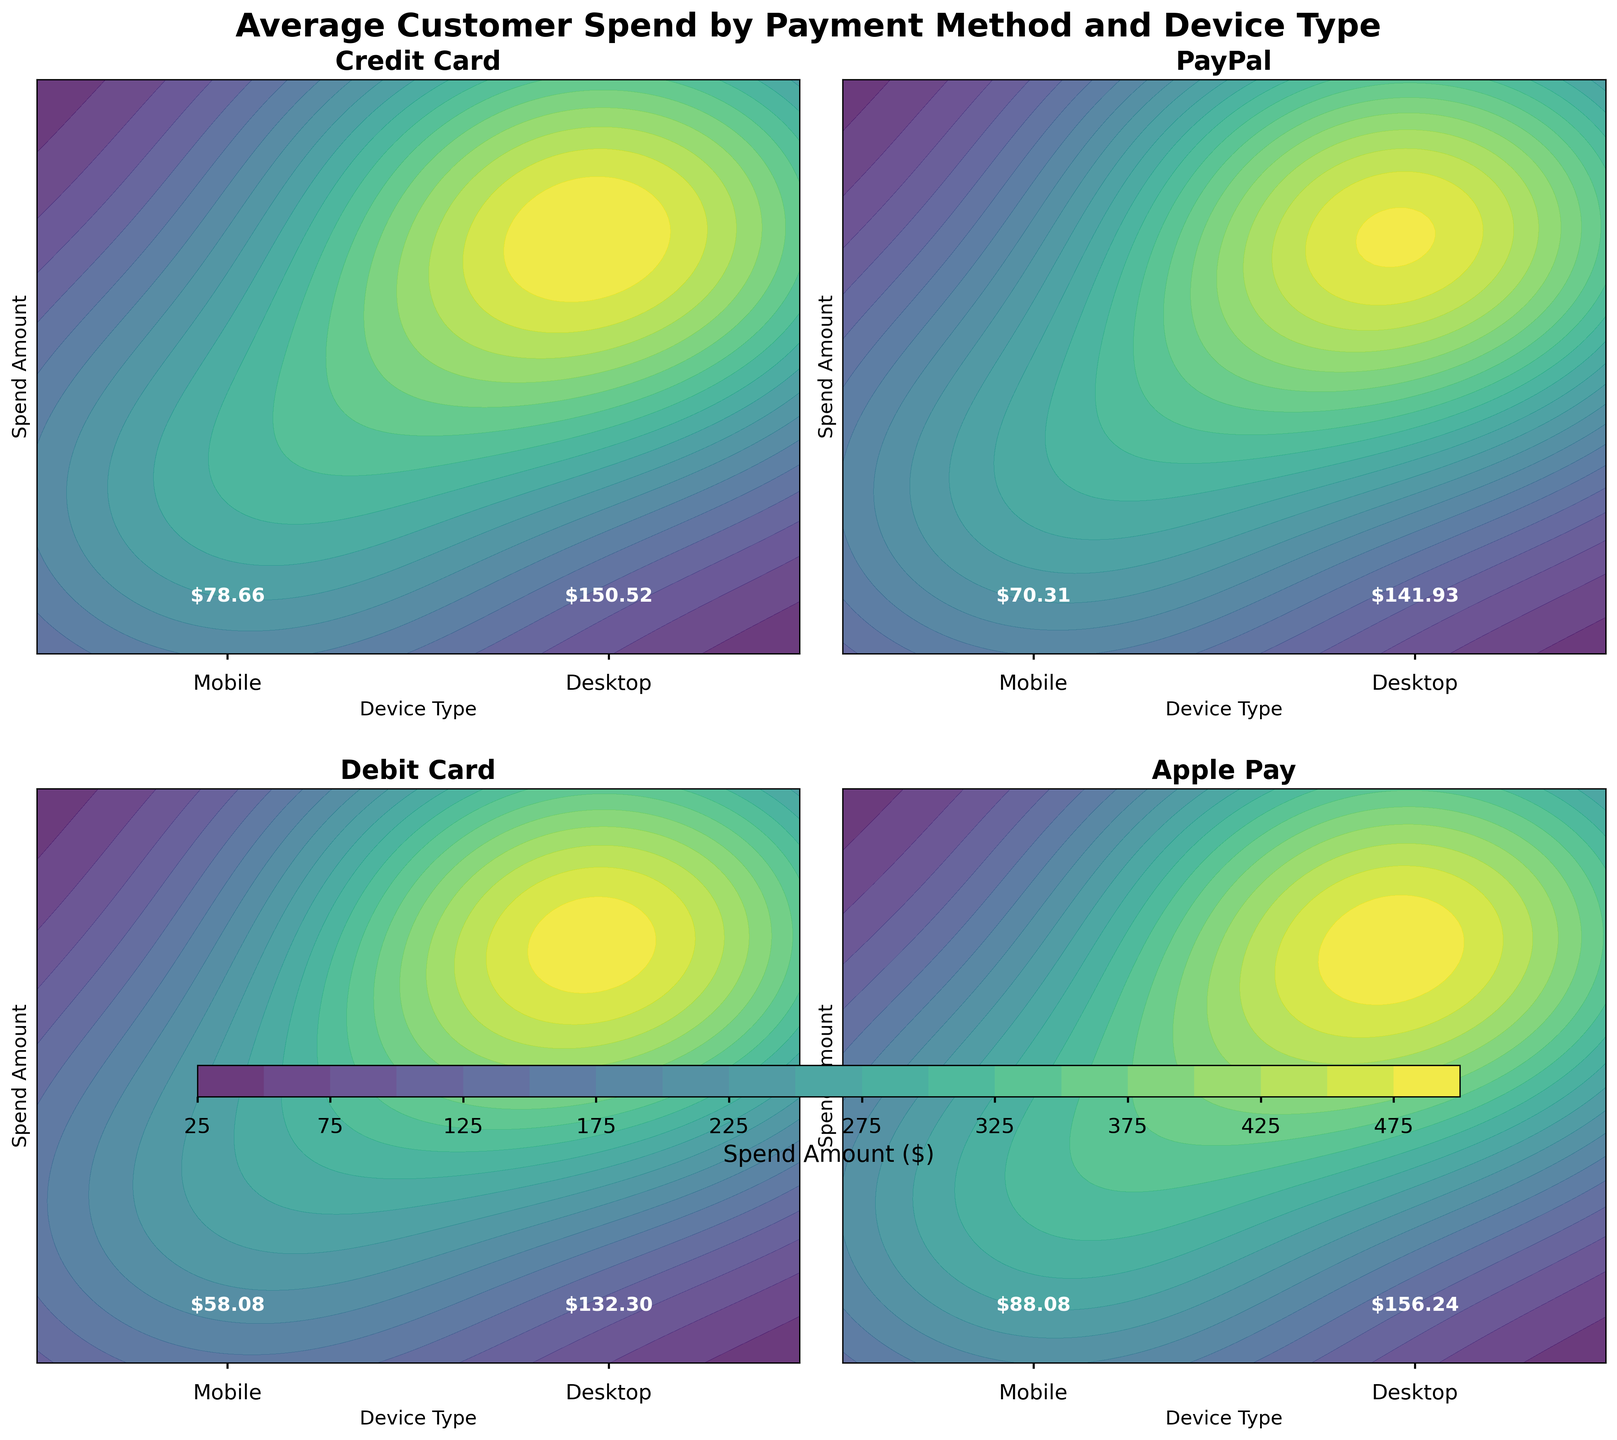What is the title of this figure? The title of the figure is displayed above the subplots and provides the overall theme or subject of the visual data presented in the plots.
Answer: Average Customer Spend by Payment Method and Device Type How many subplots are in the figure? The figure contains a grid of subplots to separately visualize data for each payment method. Counting these boxes helps identify the number of different visualizations presented.
Answer: 4 Which payment method shows the highest average customer spend for Desktop users? By examining the amounts listed next to 'Desktop' in each subplot, we identify which payment method has the highest average amount. The amount is displayed as text on the contour plot.
Answer: Apple Pay Between PayPal and Debit Card, which has a higher average spend on Mobile devices? Calculate the average of the given amounts for Mobile under each payment method and compare the resulting values. PayPal's Mobile average is 70.31, while Debit Card's Mobile average is 58.75.
Answer: PayPal What is the average spend amount for Credit Card users on Desktop devices? The amount displayed next to the 'Desktop' label in the Credit Card subplot indicates the calculated average spend for Desktop users using Credit Card.
Answer: $150.52 How do the average spend amounts compare between Mobile and Desktop users for Apple Pay? Compare the amount displayed for 'Mobile' and 'Desktop' in the Apple Pay subplot to see the difference in average spend. Apple Pay has $88.08 for Mobile and $156.91 for Desktop.
Answer: Desktop users spend more than mobile users for Apple Pay Considering all payment methods, which device type generally reflects a higher average spend? By comparing the average spend amounts displayed for each payment method under 'Mobile' and 'Desktop,' we observe that Desktop tends to have higher values on average.
Answer: Desktop What is the color gradient used to represent the spend amount on the contours? The contour plots use a color gradient to visually differentiate spend amounts. The legend or color bar often shows this information.
Answer: viridis Can you identify a trend in spending habits with respect to device types? Each subplot shows that the average spend amount for 'Desktop' is consistently higher than for 'Mobile,' indicating a trend that customers tend to spend more when using Desktop.
Answer: Spend higher on Desktop 